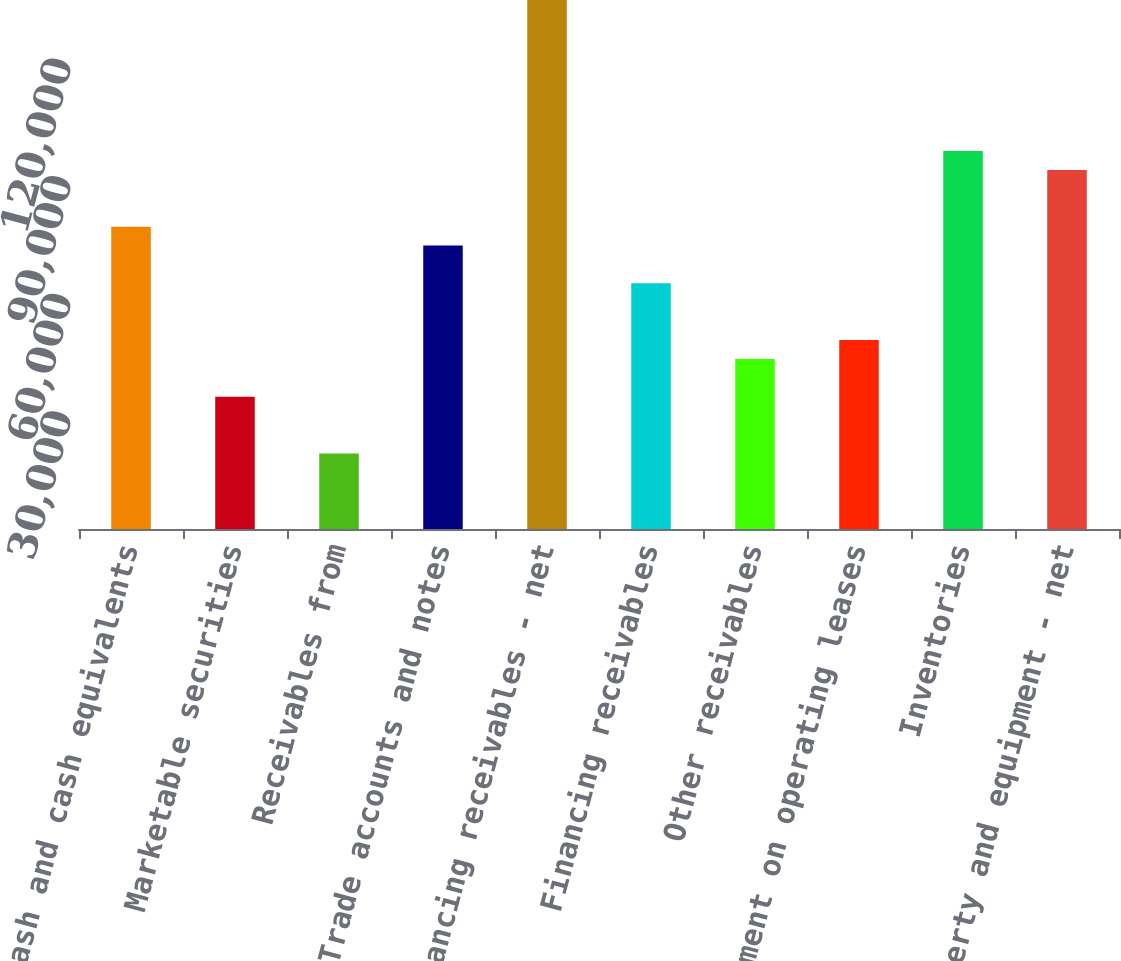<chart> <loc_0><loc_0><loc_500><loc_500><bar_chart><fcel>Cash and cash equivalents<fcel>Marketable securities<fcel>Receivables from<fcel>Trade accounts and notes<fcel>Financing receivables - net<fcel>Financing receivables<fcel>Other receivables<fcel>Equipment on operating leases<fcel>Inventories<fcel>Property and equipment - net<nl><fcel>77126.9<fcel>33747.7<fcel>19287.9<fcel>72306.9<fcel>134966<fcel>62667.1<fcel>43387.5<fcel>48207.4<fcel>96406.5<fcel>91586.6<nl></chart> 